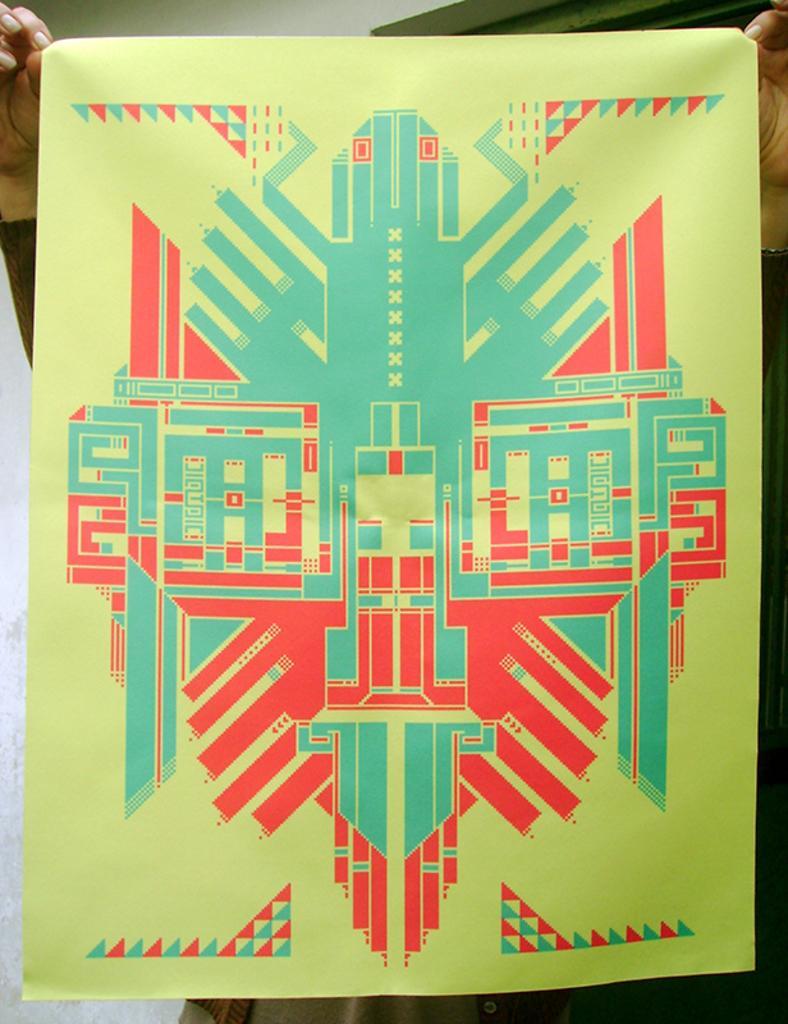How would you summarize this image in a sentence or two? In the center of the picture we can see a poster. At the top we can see the hands of a person. On the left it is looking like a wall. 